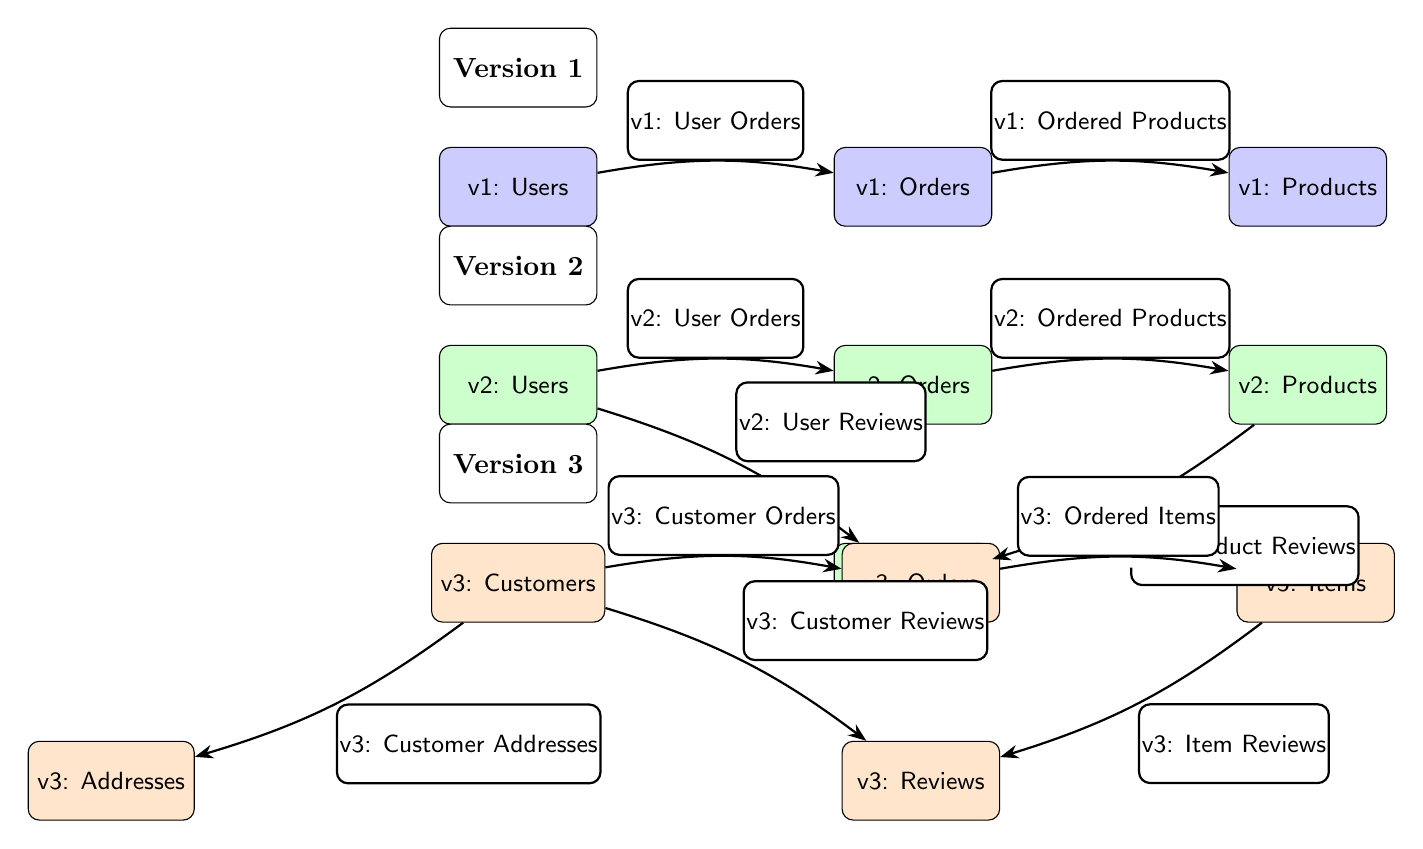What are the tables in version 1? The tables in version 1 are Users, Orders, and Products, which are clearly labeled in the diagram under the version 1 section.
Answer: Users, Orders, Products How many edges are there in version 3? In version 3, there are five edges connecting the nodes Users, Orders, Items, Reviews, and Addresses, which can be counted directly from the connections drawn in that section.
Answer: 5 What is the relationship between Customers and Orders in version 3? The relationship is denoted by the edge labeled "v3: Customer Orders," indicating that Customers place Orders.
Answer: Customer Orders Which table was added in version 2 that was not in version 1? The table Reviews was added in version 2, as it appears in the diagram under the version 2 section and is not present in version 1.
Answer: Reviews What type of items does the Orders table relate to in version 3? The Orders table relates to Items, as indicated by the edge labeled "v3: Ordered Items" connecting Orders to Items in version 3.
Answer: Items How many tables exist in the latest version? In version 3, there are five tables: Customers, Orders, Items, Reviews, and Addresses, which can be counted from the labeled nodes.
Answer: 5 Which two tables have a direct relationship in version 2? In version 2, the tables Users and Orders have a direct relationship indicated by the edge labeled "v2: User Orders."
Answer: Users, Orders What was the evolution from version 1 to version 2 regarding user interactions? In version 2, the introduction of the Reviews table allows Users to provide Reviews, showcasing an evolution in user interactions with the addition of feedback on products.
Answer: Reviews What do the arrows signify in the diagram? The arrows signify the relationships between different tables, demonstrating how entities such as Users interact with Orders and Products across the versions.
Answer: Relationships 